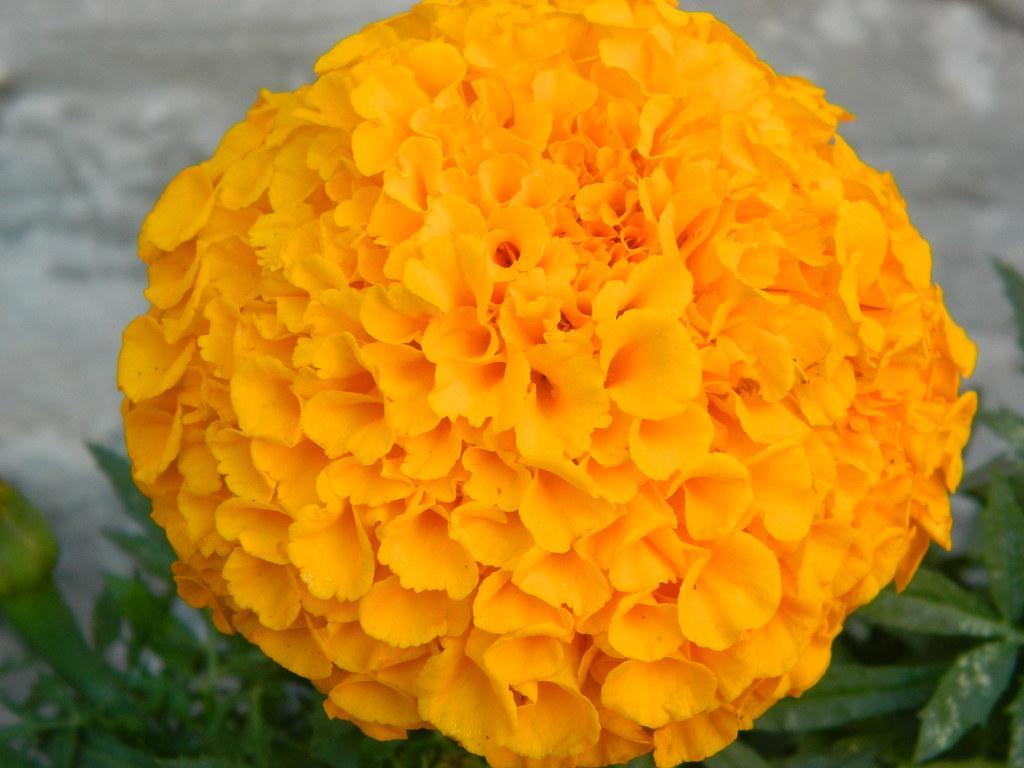Please provide a concise description of this image. This picture contains a flower which is in yellow color. At the bottom of the picture, we see plants and in the background, it is grey in color and it is blurred. 